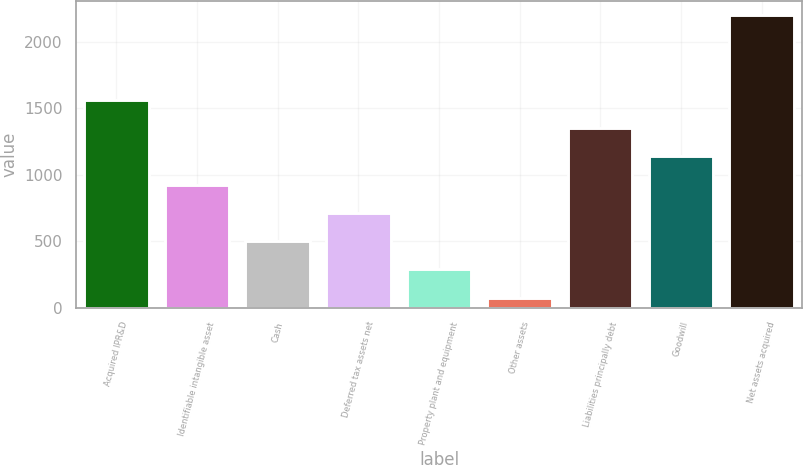Convert chart. <chart><loc_0><loc_0><loc_500><loc_500><bar_chart><fcel>Acquired IPR&D<fcel>Identifiable intangible asset<fcel>Cash<fcel>Deferred tax assets net<fcel>Property plant and equipment<fcel>Other assets<fcel>Liabilities principally debt<fcel>Goodwill<fcel>Net assets acquired<nl><fcel>1561.8<fcel>924.6<fcel>499.8<fcel>712.2<fcel>287.4<fcel>75<fcel>1349.4<fcel>1137<fcel>2199<nl></chart> 